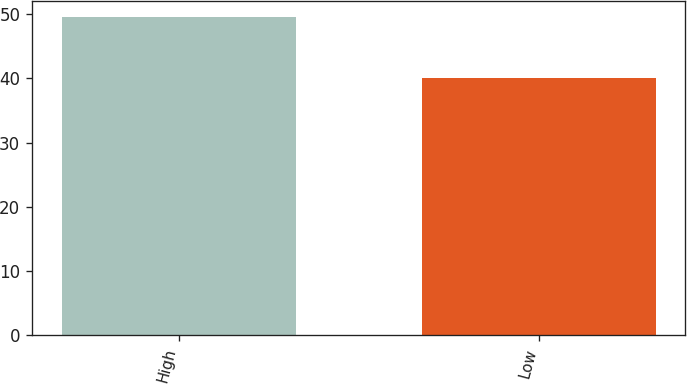Convert chart. <chart><loc_0><loc_0><loc_500><loc_500><bar_chart><fcel>High<fcel>Low<nl><fcel>49.54<fcel>40.12<nl></chart> 